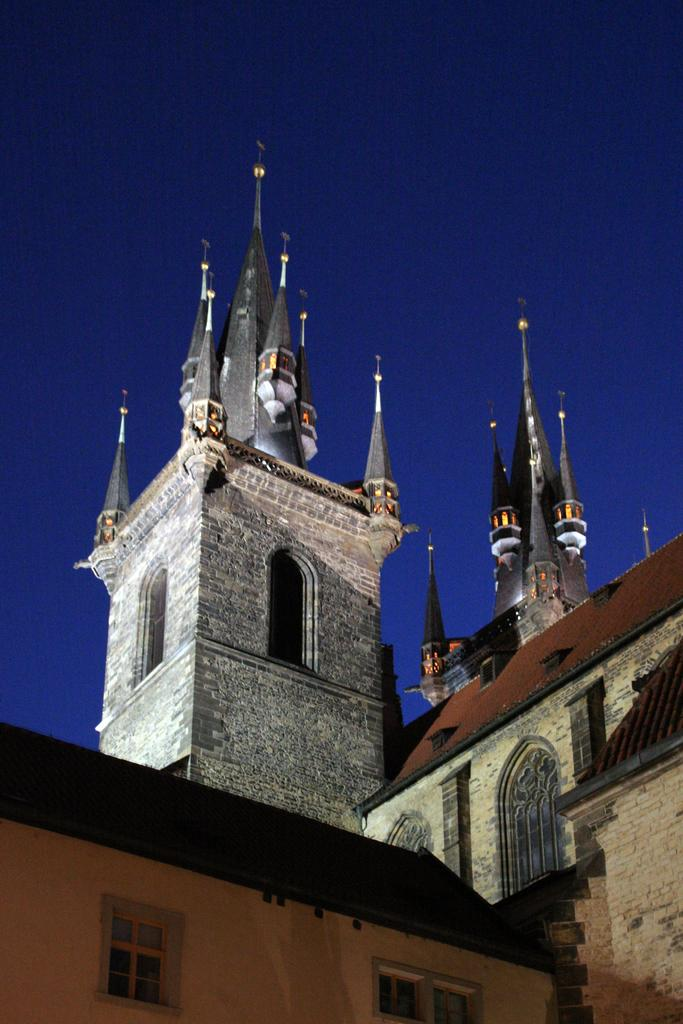What color is the sky in the image? The sky is blue in the image. What type of structures can be seen in the image? There are buildings with windows in the image. What type of cheese is being used to sing a song in the image? There is no cheese or singing in the image; it only features a blue sky and buildings with windows. 